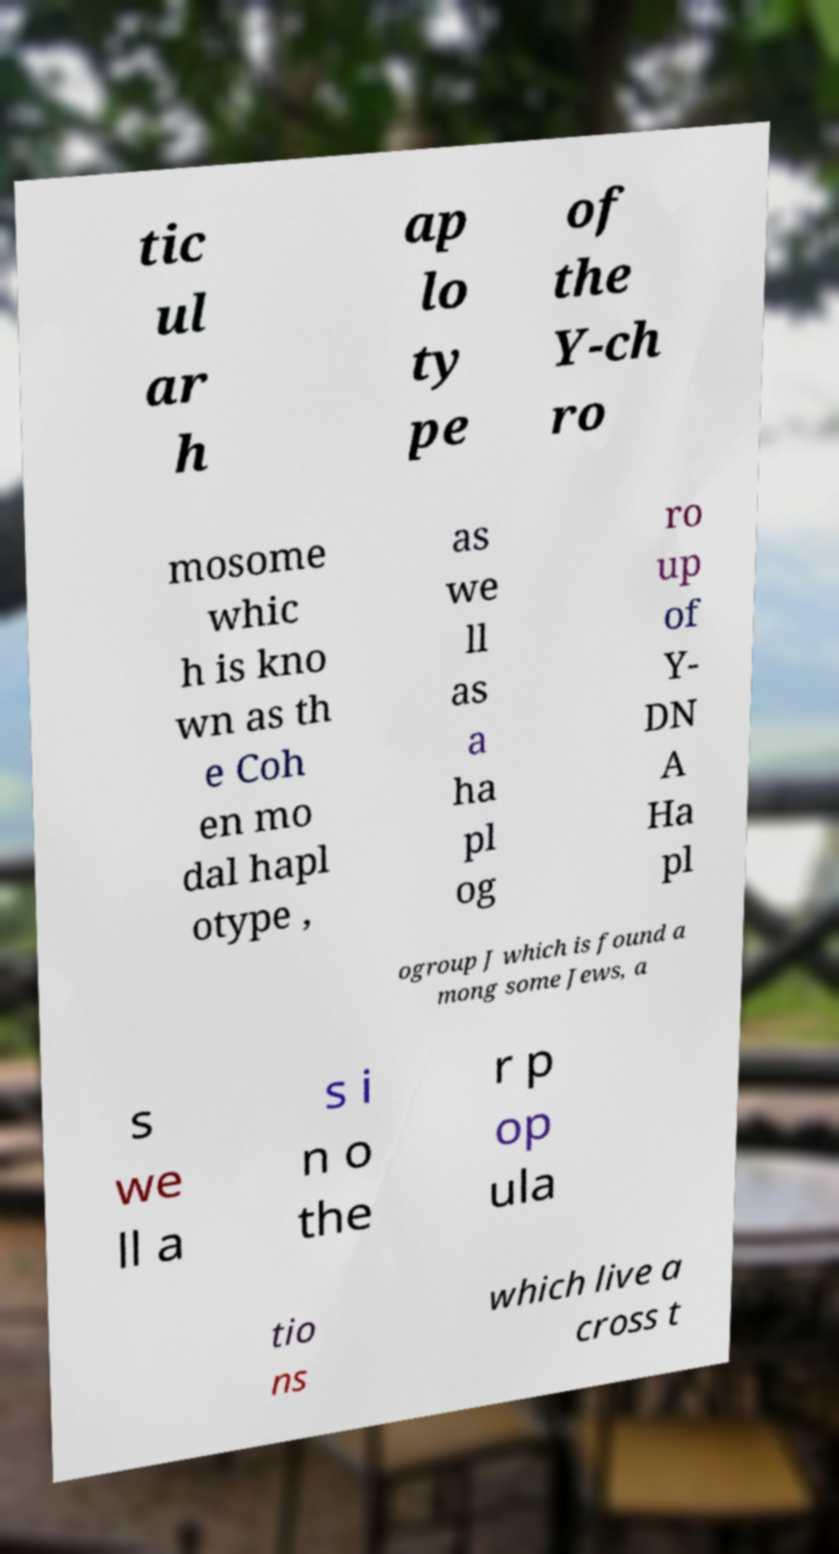Could you assist in decoding the text presented in this image and type it out clearly? tic ul ar h ap lo ty pe of the Y-ch ro mosome whic h is kno wn as th e Coh en mo dal hapl otype , as we ll as a ha pl og ro up of Y- DN A Ha pl ogroup J which is found a mong some Jews, a s we ll a s i n o the r p op ula tio ns which live a cross t 